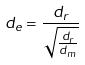<formula> <loc_0><loc_0><loc_500><loc_500>d _ { e } = \frac { d _ { r } } { \sqrt { \frac { d _ { r } } { d _ { m } } } }</formula> 